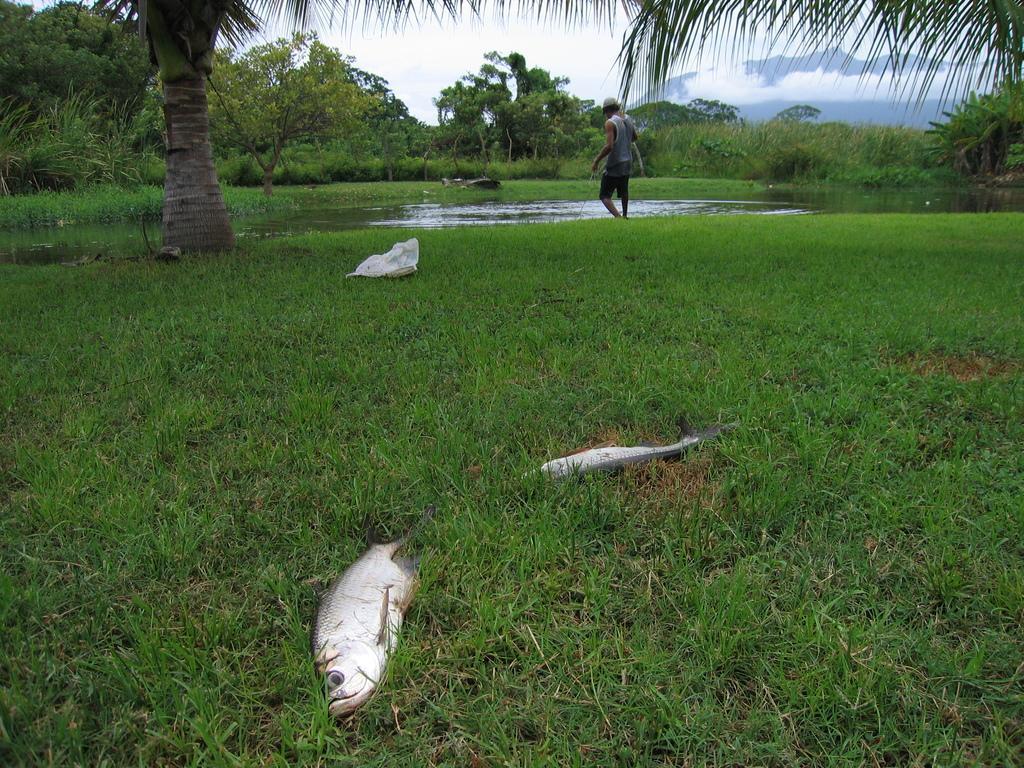How would you summarize this image in a sentence or two? At the bottom of the image we can see the fishes are present on the ground. In the background of the image we can see the trees, water, bag, grass and a man is standing and wearing a hat. At the top of the image we can see the clouds are present in the sky. At the bottom of the image we can see the ground. 